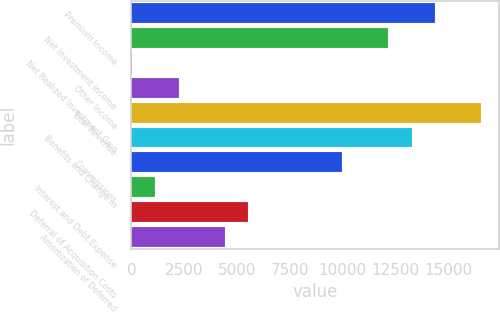<chart> <loc_0><loc_0><loc_500><loc_500><bar_chart><fcel>Premium Income<fcel>Net Investment Income<fcel>Net Realized Investment Gain<fcel>Other Income<fcel>Total Revenue<fcel>Benefits and Change in<fcel>Commissions<fcel>Interest and Debt Expense<fcel>Deferral of Acquisition Costs<fcel>Amortization of Deferred<nl><fcel>14353.2<fcel>12148.7<fcel>24.2<fcel>2228.66<fcel>16557.7<fcel>13251<fcel>9944.27<fcel>1126.43<fcel>5535.35<fcel>4433.12<nl></chart> 